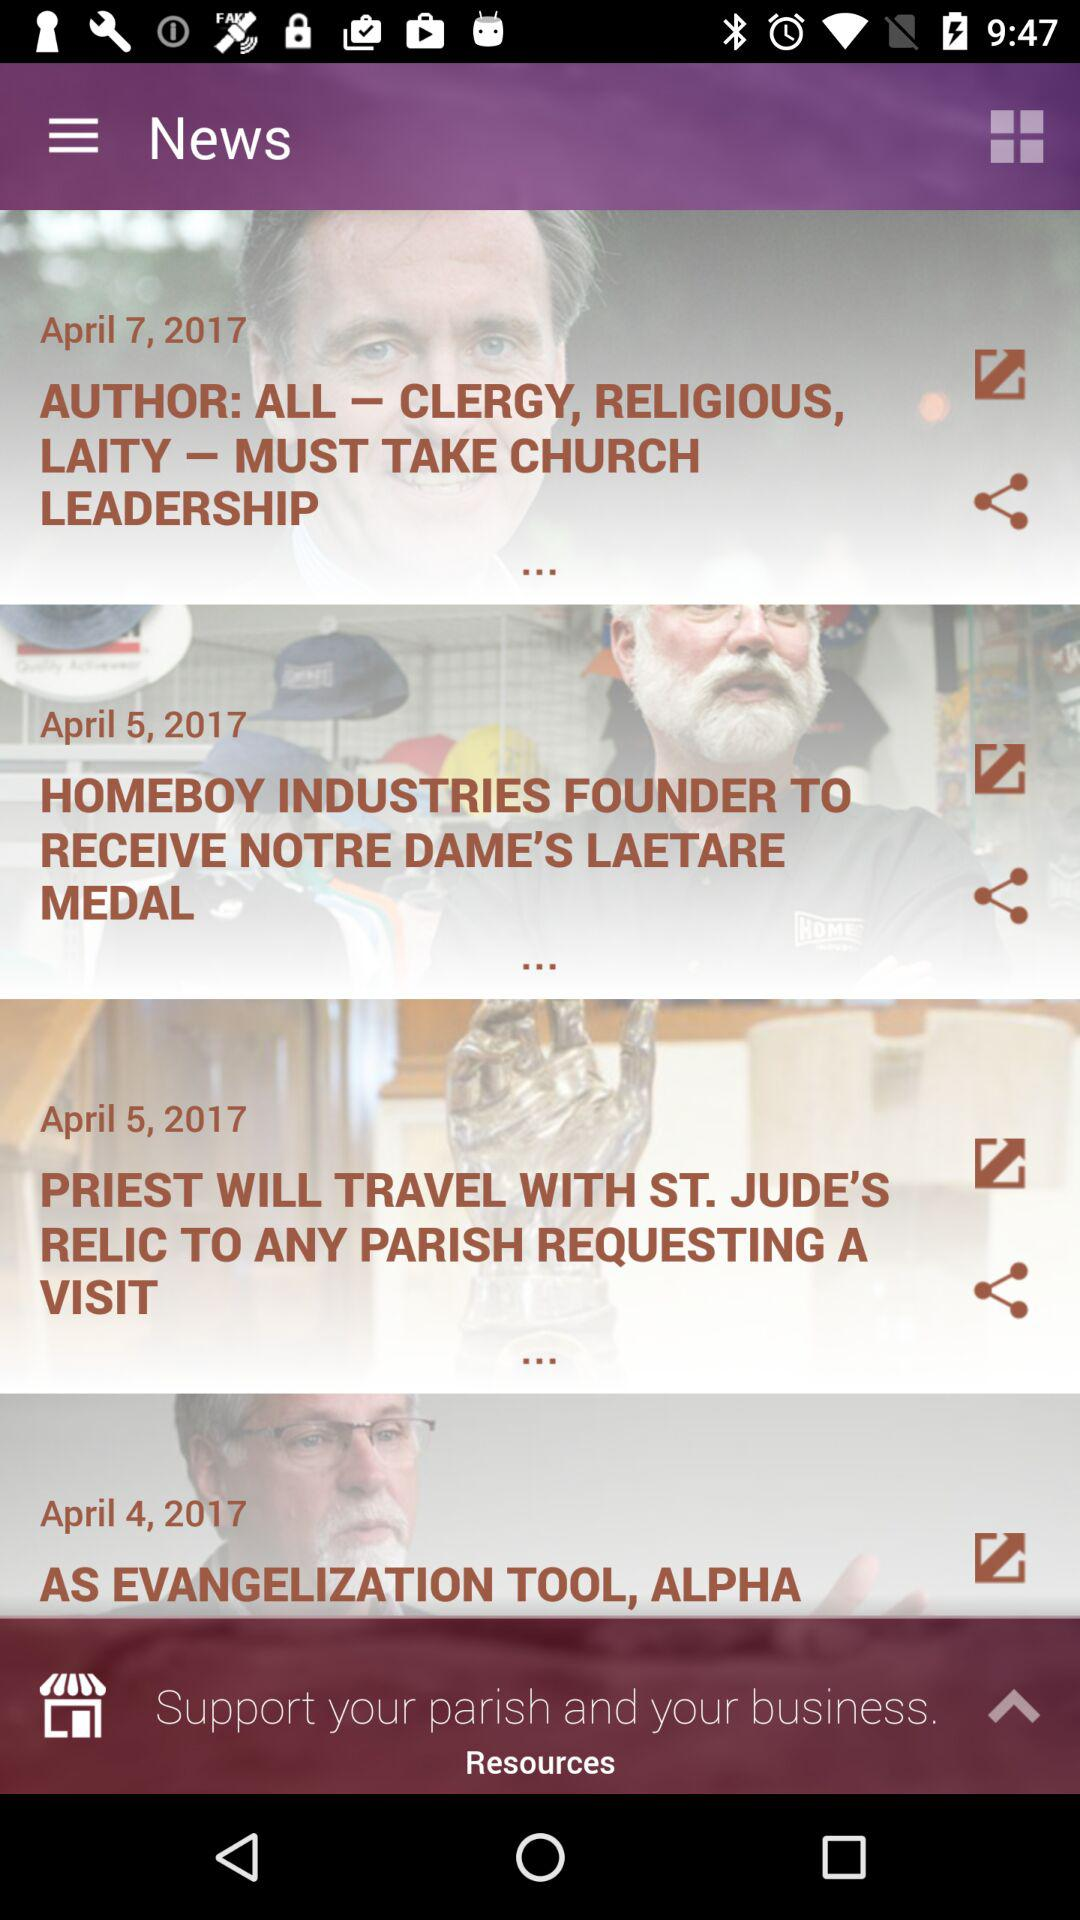On which date was the news "AS EVANGELIZATION TOOL, ALPHA" posted? The news was posted on April 4, 2017. 